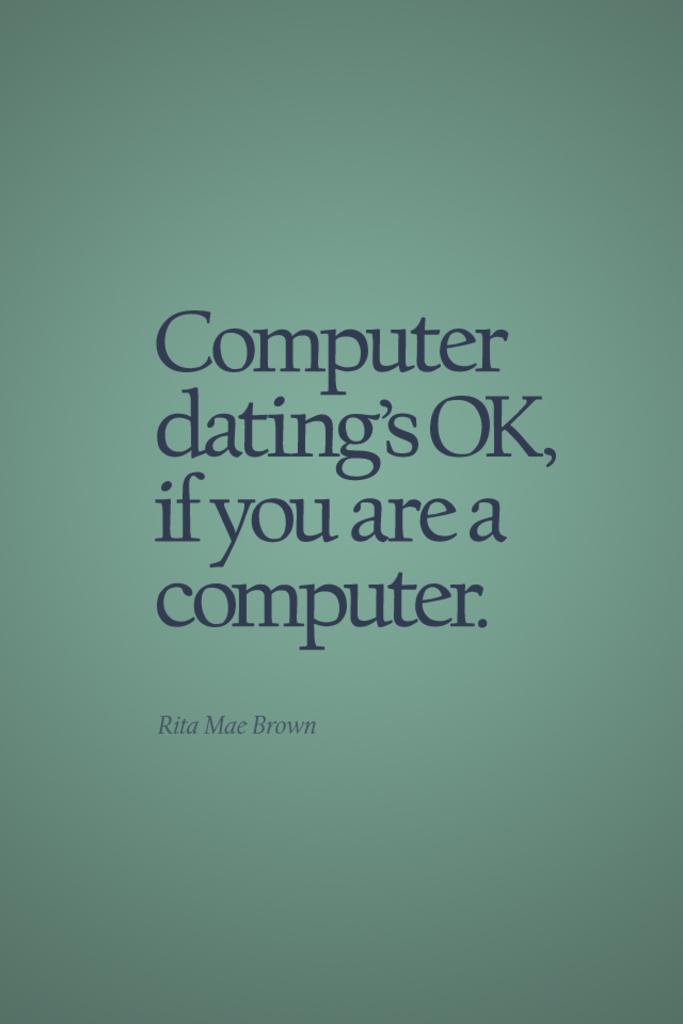Who said this quote?
Your answer should be compact. Rita mae brown. 